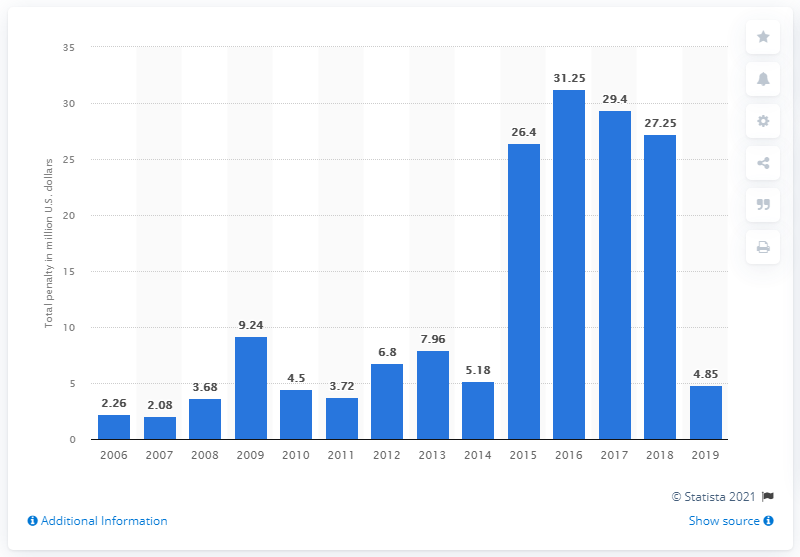Outline some significant characteristics in this image. In the fiscal year 2019, the Consumer Product Safety Commission (CPSC) imposed a total fine of $4.85 million on various companies for violating consumer product safety regulations. 